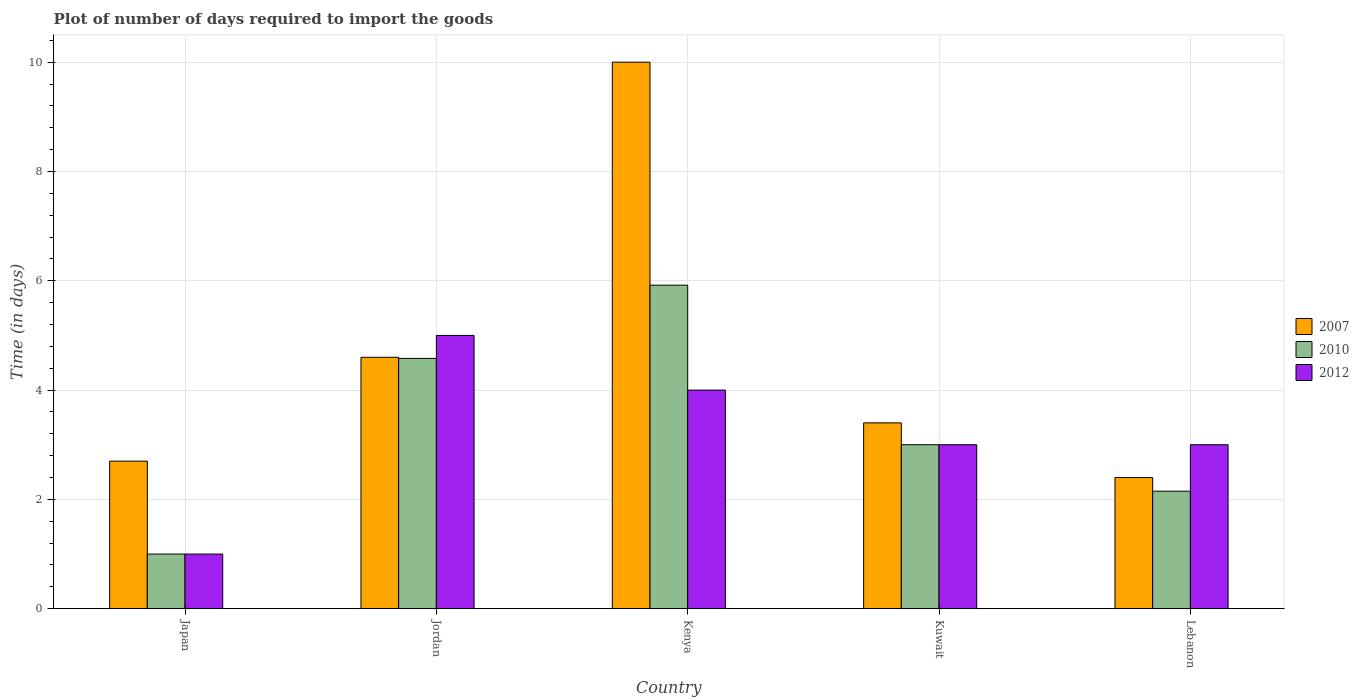How many different coloured bars are there?
Provide a succinct answer. 3. How many groups of bars are there?
Offer a terse response. 5. Are the number of bars per tick equal to the number of legend labels?
Your response must be concise. Yes. Are the number of bars on each tick of the X-axis equal?
Your answer should be compact. Yes. How many bars are there on the 1st tick from the left?
Give a very brief answer. 3. What is the label of the 5th group of bars from the left?
Your answer should be very brief. Lebanon. What is the time required to import goods in 2012 in Jordan?
Your answer should be very brief. 5. Across all countries, what is the maximum time required to import goods in 2010?
Offer a terse response. 5.92. In which country was the time required to import goods in 2012 maximum?
Your answer should be compact. Jordan. In which country was the time required to import goods in 2007 minimum?
Keep it short and to the point. Lebanon. What is the total time required to import goods in 2010 in the graph?
Give a very brief answer. 16.65. What is the difference between the time required to import goods in 2010 in Kenya and that in Lebanon?
Your response must be concise. 3.77. What is the difference between the time required to import goods in 2010 in Kenya and the time required to import goods in 2012 in Jordan?
Your response must be concise. 0.92. What is the average time required to import goods in 2007 per country?
Provide a succinct answer. 4.62. What is the difference between the time required to import goods of/in 2007 and time required to import goods of/in 2010 in Jordan?
Ensure brevity in your answer.  0.02. In how many countries, is the time required to import goods in 2012 greater than 3.6 days?
Make the answer very short. 2. What is the ratio of the time required to import goods in 2010 in Kenya to that in Lebanon?
Provide a short and direct response. 2.75. Is the time required to import goods in 2007 in Jordan less than that in Kuwait?
Offer a terse response. No. Is the difference between the time required to import goods in 2007 in Jordan and Kuwait greater than the difference between the time required to import goods in 2010 in Jordan and Kuwait?
Offer a terse response. No. What is the difference between the highest and the second highest time required to import goods in 2010?
Give a very brief answer. -1.58. What does the 2nd bar from the right in Kuwait represents?
Keep it short and to the point. 2010. How many countries are there in the graph?
Offer a terse response. 5. What is the difference between two consecutive major ticks on the Y-axis?
Provide a short and direct response. 2. How many legend labels are there?
Ensure brevity in your answer.  3. What is the title of the graph?
Ensure brevity in your answer.  Plot of number of days required to import the goods. What is the label or title of the Y-axis?
Make the answer very short. Time (in days). What is the Time (in days) of 2007 in Japan?
Your answer should be very brief. 2.7. What is the Time (in days) of 2012 in Japan?
Provide a short and direct response. 1. What is the Time (in days) of 2007 in Jordan?
Keep it short and to the point. 4.6. What is the Time (in days) of 2010 in Jordan?
Your answer should be very brief. 4.58. What is the Time (in days) in 2010 in Kenya?
Your response must be concise. 5.92. What is the Time (in days) of 2012 in Kenya?
Give a very brief answer. 4. What is the Time (in days) of 2010 in Kuwait?
Your answer should be very brief. 3. What is the Time (in days) of 2010 in Lebanon?
Your answer should be compact. 2.15. What is the Time (in days) in 2012 in Lebanon?
Make the answer very short. 3. Across all countries, what is the maximum Time (in days) of 2010?
Your answer should be very brief. 5.92. Across all countries, what is the minimum Time (in days) in 2010?
Provide a short and direct response. 1. Across all countries, what is the minimum Time (in days) in 2012?
Your answer should be very brief. 1. What is the total Time (in days) in 2007 in the graph?
Offer a terse response. 23.1. What is the total Time (in days) in 2010 in the graph?
Your response must be concise. 16.65. What is the total Time (in days) in 2012 in the graph?
Your answer should be compact. 16. What is the difference between the Time (in days) in 2010 in Japan and that in Jordan?
Offer a terse response. -3.58. What is the difference between the Time (in days) in 2012 in Japan and that in Jordan?
Keep it short and to the point. -4. What is the difference between the Time (in days) in 2007 in Japan and that in Kenya?
Your answer should be compact. -7.3. What is the difference between the Time (in days) of 2010 in Japan and that in Kenya?
Provide a succinct answer. -4.92. What is the difference between the Time (in days) in 2012 in Japan and that in Kenya?
Provide a short and direct response. -3. What is the difference between the Time (in days) of 2007 in Japan and that in Kuwait?
Your answer should be very brief. -0.7. What is the difference between the Time (in days) in 2010 in Japan and that in Kuwait?
Keep it short and to the point. -2. What is the difference between the Time (in days) in 2010 in Japan and that in Lebanon?
Provide a succinct answer. -1.15. What is the difference between the Time (in days) of 2012 in Japan and that in Lebanon?
Provide a short and direct response. -2. What is the difference between the Time (in days) of 2010 in Jordan and that in Kenya?
Offer a very short reply. -1.34. What is the difference between the Time (in days) of 2012 in Jordan and that in Kenya?
Offer a terse response. 1. What is the difference between the Time (in days) in 2007 in Jordan and that in Kuwait?
Make the answer very short. 1.2. What is the difference between the Time (in days) in 2010 in Jordan and that in Kuwait?
Offer a very short reply. 1.58. What is the difference between the Time (in days) of 2010 in Jordan and that in Lebanon?
Your answer should be very brief. 2.43. What is the difference between the Time (in days) in 2007 in Kenya and that in Kuwait?
Make the answer very short. 6.6. What is the difference between the Time (in days) of 2010 in Kenya and that in Kuwait?
Your answer should be very brief. 2.92. What is the difference between the Time (in days) of 2012 in Kenya and that in Kuwait?
Ensure brevity in your answer.  1. What is the difference between the Time (in days) in 2007 in Kenya and that in Lebanon?
Give a very brief answer. 7.6. What is the difference between the Time (in days) in 2010 in Kenya and that in Lebanon?
Your answer should be compact. 3.77. What is the difference between the Time (in days) of 2012 in Kenya and that in Lebanon?
Make the answer very short. 1. What is the difference between the Time (in days) of 2007 in Kuwait and that in Lebanon?
Offer a terse response. 1. What is the difference between the Time (in days) in 2007 in Japan and the Time (in days) in 2010 in Jordan?
Make the answer very short. -1.88. What is the difference between the Time (in days) in 2007 in Japan and the Time (in days) in 2012 in Jordan?
Make the answer very short. -2.3. What is the difference between the Time (in days) of 2010 in Japan and the Time (in days) of 2012 in Jordan?
Provide a short and direct response. -4. What is the difference between the Time (in days) of 2007 in Japan and the Time (in days) of 2010 in Kenya?
Your answer should be compact. -3.22. What is the difference between the Time (in days) of 2007 in Japan and the Time (in days) of 2012 in Kenya?
Provide a succinct answer. -1.3. What is the difference between the Time (in days) of 2010 in Japan and the Time (in days) of 2012 in Kenya?
Provide a short and direct response. -3. What is the difference between the Time (in days) of 2007 in Japan and the Time (in days) of 2010 in Kuwait?
Keep it short and to the point. -0.3. What is the difference between the Time (in days) in 2007 in Japan and the Time (in days) in 2012 in Kuwait?
Provide a short and direct response. -0.3. What is the difference between the Time (in days) of 2010 in Japan and the Time (in days) of 2012 in Kuwait?
Your response must be concise. -2. What is the difference between the Time (in days) in 2007 in Japan and the Time (in days) in 2010 in Lebanon?
Provide a short and direct response. 0.55. What is the difference between the Time (in days) of 2010 in Japan and the Time (in days) of 2012 in Lebanon?
Your answer should be very brief. -2. What is the difference between the Time (in days) in 2007 in Jordan and the Time (in days) in 2010 in Kenya?
Provide a short and direct response. -1.32. What is the difference between the Time (in days) of 2007 in Jordan and the Time (in days) of 2012 in Kenya?
Your answer should be compact. 0.6. What is the difference between the Time (in days) of 2010 in Jordan and the Time (in days) of 2012 in Kenya?
Give a very brief answer. 0.58. What is the difference between the Time (in days) in 2010 in Jordan and the Time (in days) in 2012 in Kuwait?
Offer a terse response. 1.58. What is the difference between the Time (in days) of 2007 in Jordan and the Time (in days) of 2010 in Lebanon?
Offer a very short reply. 2.45. What is the difference between the Time (in days) of 2010 in Jordan and the Time (in days) of 2012 in Lebanon?
Offer a very short reply. 1.58. What is the difference between the Time (in days) in 2007 in Kenya and the Time (in days) in 2010 in Kuwait?
Keep it short and to the point. 7. What is the difference between the Time (in days) in 2007 in Kenya and the Time (in days) in 2012 in Kuwait?
Your answer should be very brief. 7. What is the difference between the Time (in days) of 2010 in Kenya and the Time (in days) of 2012 in Kuwait?
Your response must be concise. 2.92. What is the difference between the Time (in days) in 2007 in Kenya and the Time (in days) in 2010 in Lebanon?
Your response must be concise. 7.85. What is the difference between the Time (in days) of 2007 in Kenya and the Time (in days) of 2012 in Lebanon?
Offer a terse response. 7. What is the difference between the Time (in days) of 2010 in Kenya and the Time (in days) of 2012 in Lebanon?
Your answer should be very brief. 2.92. What is the difference between the Time (in days) of 2007 in Kuwait and the Time (in days) of 2010 in Lebanon?
Offer a very short reply. 1.25. What is the difference between the Time (in days) in 2010 in Kuwait and the Time (in days) in 2012 in Lebanon?
Keep it short and to the point. 0. What is the average Time (in days) in 2007 per country?
Your answer should be very brief. 4.62. What is the average Time (in days) of 2010 per country?
Provide a short and direct response. 3.33. What is the average Time (in days) in 2012 per country?
Your answer should be very brief. 3.2. What is the difference between the Time (in days) in 2007 and Time (in days) in 2012 in Japan?
Make the answer very short. 1.7. What is the difference between the Time (in days) of 2007 and Time (in days) of 2010 in Jordan?
Keep it short and to the point. 0.02. What is the difference between the Time (in days) of 2010 and Time (in days) of 2012 in Jordan?
Offer a very short reply. -0.42. What is the difference between the Time (in days) in 2007 and Time (in days) in 2010 in Kenya?
Offer a terse response. 4.08. What is the difference between the Time (in days) of 2010 and Time (in days) of 2012 in Kenya?
Offer a very short reply. 1.92. What is the difference between the Time (in days) in 2007 and Time (in days) in 2010 in Kuwait?
Your answer should be compact. 0.4. What is the difference between the Time (in days) in 2010 and Time (in days) in 2012 in Kuwait?
Make the answer very short. 0. What is the difference between the Time (in days) of 2010 and Time (in days) of 2012 in Lebanon?
Your response must be concise. -0.85. What is the ratio of the Time (in days) of 2007 in Japan to that in Jordan?
Offer a very short reply. 0.59. What is the ratio of the Time (in days) in 2010 in Japan to that in Jordan?
Your response must be concise. 0.22. What is the ratio of the Time (in days) of 2012 in Japan to that in Jordan?
Offer a very short reply. 0.2. What is the ratio of the Time (in days) of 2007 in Japan to that in Kenya?
Your answer should be compact. 0.27. What is the ratio of the Time (in days) in 2010 in Japan to that in Kenya?
Provide a succinct answer. 0.17. What is the ratio of the Time (in days) in 2012 in Japan to that in Kenya?
Ensure brevity in your answer.  0.25. What is the ratio of the Time (in days) in 2007 in Japan to that in Kuwait?
Give a very brief answer. 0.79. What is the ratio of the Time (in days) of 2010 in Japan to that in Kuwait?
Your answer should be compact. 0.33. What is the ratio of the Time (in days) in 2007 in Japan to that in Lebanon?
Keep it short and to the point. 1.12. What is the ratio of the Time (in days) in 2010 in Japan to that in Lebanon?
Provide a short and direct response. 0.47. What is the ratio of the Time (in days) in 2012 in Japan to that in Lebanon?
Your answer should be very brief. 0.33. What is the ratio of the Time (in days) of 2007 in Jordan to that in Kenya?
Offer a terse response. 0.46. What is the ratio of the Time (in days) in 2010 in Jordan to that in Kenya?
Offer a terse response. 0.77. What is the ratio of the Time (in days) of 2007 in Jordan to that in Kuwait?
Keep it short and to the point. 1.35. What is the ratio of the Time (in days) of 2010 in Jordan to that in Kuwait?
Your answer should be very brief. 1.53. What is the ratio of the Time (in days) in 2012 in Jordan to that in Kuwait?
Your answer should be compact. 1.67. What is the ratio of the Time (in days) in 2007 in Jordan to that in Lebanon?
Your answer should be very brief. 1.92. What is the ratio of the Time (in days) of 2010 in Jordan to that in Lebanon?
Make the answer very short. 2.13. What is the ratio of the Time (in days) in 2012 in Jordan to that in Lebanon?
Your response must be concise. 1.67. What is the ratio of the Time (in days) of 2007 in Kenya to that in Kuwait?
Your answer should be very brief. 2.94. What is the ratio of the Time (in days) of 2010 in Kenya to that in Kuwait?
Your response must be concise. 1.97. What is the ratio of the Time (in days) of 2007 in Kenya to that in Lebanon?
Offer a very short reply. 4.17. What is the ratio of the Time (in days) of 2010 in Kenya to that in Lebanon?
Provide a short and direct response. 2.75. What is the ratio of the Time (in days) in 2012 in Kenya to that in Lebanon?
Make the answer very short. 1.33. What is the ratio of the Time (in days) in 2007 in Kuwait to that in Lebanon?
Your answer should be compact. 1.42. What is the ratio of the Time (in days) in 2010 in Kuwait to that in Lebanon?
Your answer should be very brief. 1.4. What is the ratio of the Time (in days) of 2012 in Kuwait to that in Lebanon?
Your answer should be very brief. 1. What is the difference between the highest and the second highest Time (in days) in 2007?
Provide a short and direct response. 5.4. What is the difference between the highest and the second highest Time (in days) of 2010?
Provide a short and direct response. 1.34. What is the difference between the highest and the lowest Time (in days) of 2010?
Your answer should be very brief. 4.92. 